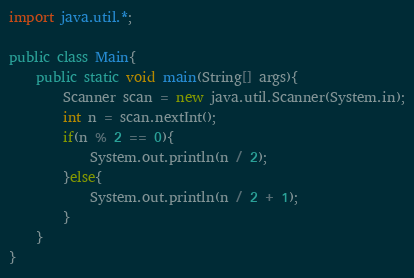<code> <loc_0><loc_0><loc_500><loc_500><_Java_>import java.util.*;

public class Main{
    public static void main(String[] args){
        Scanner scan = new java.util.Scanner(System.in);
        int n = scan.nextInt();
        if(n % 2 == 0){
            System.out.println(n / 2);
        }else{
            System.out.println(n / 2 + 1);
        }
    }
}</code> 